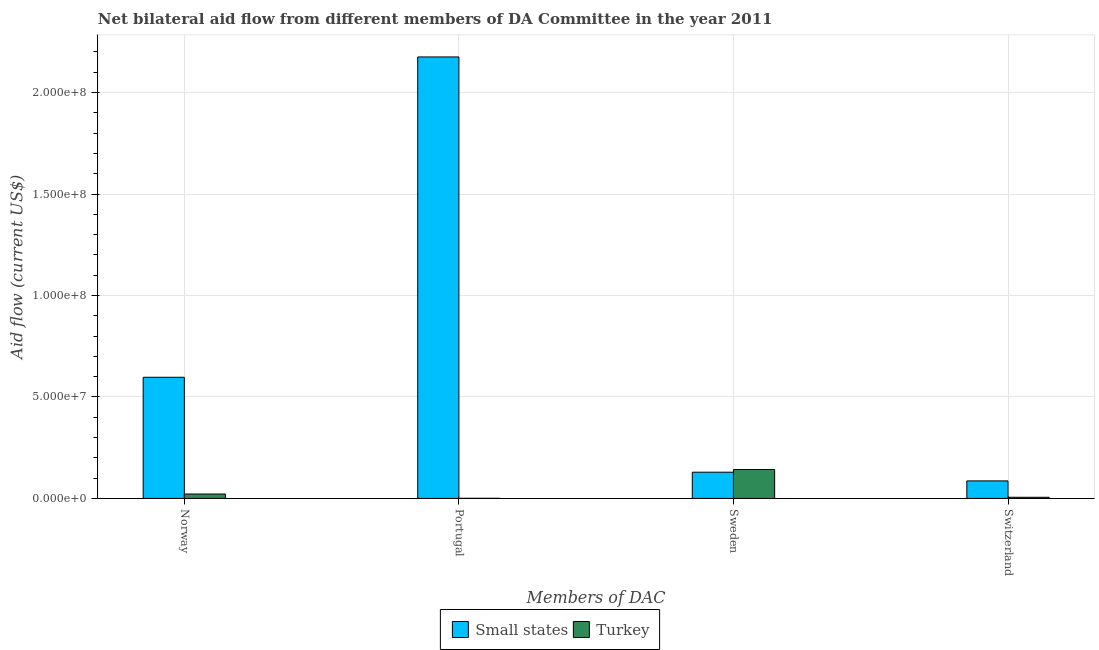How many different coloured bars are there?
Keep it short and to the point. 2. Are the number of bars per tick equal to the number of legend labels?
Your answer should be compact. Yes. Are the number of bars on each tick of the X-axis equal?
Offer a very short reply. Yes. How many bars are there on the 1st tick from the right?
Make the answer very short. 2. What is the label of the 3rd group of bars from the left?
Keep it short and to the point. Sweden. What is the amount of aid given by sweden in Small states?
Provide a short and direct response. 1.29e+07. Across all countries, what is the maximum amount of aid given by switzerland?
Your answer should be very brief. 8.64e+06. Across all countries, what is the minimum amount of aid given by sweden?
Ensure brevity in your answer.  1.29e+07. In which country was the amount of aid given by sweden maximum?
Provide a short and direct response. Turkey. In which country was the amount of aid given by portugal minimum?
Your answer should be very brief. Turkey. What is the total amount of aid given by norway in the graph?
Provide a short and direct response. 6.19e+07. What is the difference between the amount of aid given by sweden in Turkey and that in Small states?
Make the answer very short. 1.32e+06. What is the difference between the amount of aid given by sweden in Turkey and the amount of aid given by norway in Small states?
Your answer should be very brief. -4.54e+07. What is the average amount of aid given by switzerland per country?
Make the answer very short. 4.60e+06. What is the difference between the amount of aid given by norway and amount of aid given by sweden in Turkey?
Provide a succinct answer. -1.21e+07. What is the ratio of the amount of aid given by sweden in Small states to that in Turkey?
Ensure brevity in your answer.  0.91. Is the amount of aid given by switzerland in Small states less than that in Turkey?
Provide a short and direct response. No. Is the difference between the amount of aid given by switzerland in Turkey and Small states greater than the difference between the amount of aid given by sweden in Turkey and Small states?
Provide a short and direct response. No. What is the difference between the highest and the second highest amount of aid given by sweden?
Provide a succinct answer. 1.32e+06. What is the difference between the highest and the lowest amount of aid given by portugal?
Your answer should be very brief. 2.17e+08. In how many countries, is the amount of aid given by switzerland greater than the average amount of aid given by switzerland taken over all countries?
Keep it short and to the point. 1. Is it the case that in every country, the sum of the amount of aid given by switzerland and amount of aid given by norway is greater than the sum of amount of aid given by portugal and amount of aid given by sweden?
Offer a terse response. No. What does the 2nd bar from the left in Portugal represents?
Provide a succinct answer. Turkey. What does the 2nd bar from the right in Norway represents?
Your answer should be very brief. Small states. How many bars are there?
Ensure brevity in your answer.  8. How many countries are there in the graph?
Give a very brief answer. 2. Are the values on the major ticks of Y-axis written in scientific E-notation?
Provide a succinct answer. Yes. Does the graph contain any zero values?
Your answer should be compact. No. How many legend labels are there?
Your answer should be compact. 2. What is the title of the graph?
Offer a terse response. Net bilateral aid flow from different members of DA Committee in the year 2011. What is the label or title of the X-axis?
Provide a succinct answer. Members of DAC. What is the Aid flow (current US$) of Small states in Norway?
Keep it short and to the point. 5.97e+07. What is the Aid flow (current US$) in Turkey in Norway?
Give a very brief answer. 2.17e+06. What is the Aid flow (current US$) of Small states in Portugal?
Give a very brief answer. 2.18e+08. What is the Aid flow (current US$) in Small states in Sweden?
Your response must be concise. 1.29e+07. What is the Aid flow (current US$) in Turkey in Sweden?
Offer a very short reply. 1.42e+07. What is the Aid flow (current US$) in Small states in Switzerland?
Offer a terse response. 8.64e+06. What is the Aid flow (current US$) of Turkey in Switzerland?
Offer a very short reply. 5.70e+05. Across all Members of DAC, what is the maximum Aid flow (current US$) of Small states?
Your answer should be very brief. 2.18e+08. Across all Members of DAC, what is the maximum Aid flow (current US$) in Turkey?
Your answer should be compact. 1.42e+07. Across all Members of DAC, what is the minimum Aid flow (current US$) in Small states?
Your answer should be compact. 8.64e+06. What is the total Aid flow (current US$) in Small states in the graph?
Offer a terse response. 2.99e+08. What is the total Aid flow (current US$) in Turkey in the graph?
Provide a succinct answer. 1.70e+07. What is the difference between the Aid flow (current US$) in Small states in Norway and that in Portugal?
Make the answer very short. -1.58e+08. What is the difference between the Aid flow (current US$) of Turkey in Norway and that in Portugal?
Keep it short and to the point. 2.11e+06. What is the difference between the Aid flow (current US$) in Small states in Norway and that in Sweden?
Provide a succinct answer. 4.68e+07. What is the difference between the Aid flow (current US$) of Turkey in Norway and that in Sweden?
Keep it short and to the point. -1.21e+07. What is the difference between the Aid flow (current US$) of Small states in Norway and that in Switzerland?
Make the answer very short. 5.11e+07. What is the difference between the Aid flow (current US$) of Turkey in Norway and that in Switzerland?
Offer a terse response. 1.60e+06. What is the difference between the Aid flow (current US$) of Small states in Portugal and that in Sweden?
Provide a short and direct response. 2.05e+08. What is the difference between the Aid flow (current US$) of Turkey in Portugal and that in Sweden?
Your answer should be compact. -1.42e+07. What is the difference between the Aid flow (current US$) of Small states in Portugal and that in Switzerland?
Ensure brevity in your answer.  2.09e+08. What is the difference between the Aid flow (current US$) of Turkey in Portugal and that in Switzerland?
Provide a succinct answer. -5.10e+05. What is the difference between the Aid flow (current US$) in Small states in Sweden and that in Switzerland?
Give a very brief answer. 4.29e+06. What is the difference between the Aid flow (current US$) of Turkey in Sweden and that in Switzerland?
Give a very brief answer. 1.37e+07. What is the difference between the Aid flow (current US$) of Small states in Norway and the Aid flow (current US$) of Turkey in Portugal?
Provide a succinct answer. 5.96e+07. What is the difference between the Aid flow (current US$) in Small states in Norway and the Aid flow (current US$) in Turkey in Sweden?
Keep it short and to the point. 4.54e+07. What is the difference between the Aid flow (current US$) of Small states in Norway and the Aid flow (current US$) of Turkey in Switzerland?
Provide a short and direct response. 5.91e+07. What is the difference between the Aid flow (current US$) of Small states in Portugal and the Aid flow (current US$) of Turkey in Sweden?
Keep it short and to the point. 2.03e+08. What is the difference between the Aid flow (current US$) of Small states in Portugal and the Aid flow (current US$) of Turkey in Switzerland?
Your answer should be compact. 2.17e+08. What is the difference between the Aid flow (current US$) of Small states in Sweden and the Aid flow (current US$) of Turkey in Switzerland?
Keep it short and to the point. 1.24e+07. What is the average Aid flow (current US$) of Small states per Members of DAC?
Your answer should be very brief. 7.47e+07. What is the average Aid flow (current US$) of Turkey per Members of DAC?
Your answer should be compact. 4.26e+06. What is the difference between the Aid flow (current US$) in Small states and Aid flow (current US$) in Turkey in Norway?
Provide a succinct answer. 5.75e+07. What is the difference between the Aid flow (current US$) in Small states and Aid flow (current US$) in Turkey in Portugal?
Make the answer very short. 2.17e+08. What is the difference between the Aid flow (current US$) in Small states and Aid flow (current US$) in Turkey in Sweden?
Keep it short and to the point. -1.32e+06. What is the difference between the Aid flow (current US$) of Small states and Aid flow (current US$) of Turkey in Switzerland?
Offer a very short reply. 8.07e+06. What is the ratio of the Aid flow (current US$) of Small states in Norway to that in Portugal?
Provide a short and direct response. 0.27. What is the ratio of the Aid flow (current US$) in Turkey in Norway to that in Portugal?
Offer a terse response. 36.17. What is the ratio of the Aid flow (current US$) in Small states in Norway to that in Sweden?
Give a very brief answer. 4.62. What is the ratio of the Aid flow (current US$) of Turkey in Norway to that in Sweden?
Give a very brief answer. 0.15. What is the ratio of the Aid flow (current US$) in Small states in Norway to that in Switzerland?
Ensure brevity in your answer.  6.91. What is the ratio of the Aid flow (current US$) in Turkey in Norway to that in Switzerland?
Keep it short and to the point. 3.81. What is the ratio of the Aid flow (current US$) of Small states in Portugal to that in Sweden?
Provide a succinct answer. 16.82. What is the ratio of the Aid flow (current US$) of Turkey in Portugal to that in Sweden?
Keep it short and to the point. 0. What is the ratio of the Aid flow (current US$) of Small states in Portugal to that in Switzerland?
Ensure brevity in your answer.  25.18. What is the ratio of the Aid flow (current US$) of Turkey in Portugal to that in Switzerland?
Offer a very short reply. 0.11. What is the ratio of the Aid flow (current US$) in Small states in Sweden to that in Switzerland?
Your answer should be very brief. 1.5. What is the ratio of the Aid flow (current US$) in Turkey in Sweden to that in Switzerland?
Your answer should be very brief. 25. What is the difference between the highest and the second highest Aid flow (current US$) in Small states?
Ensure brevity in your answer.  1.58e+08. What is the difference between the highest and the second highest Aid flow (current US$) in Turkey?
Make the answer very short. 1.21e+07. What is the difference between the highest and the lowest Aid flow (current US$) of Small states?
Your answer should be compact. 2.09e+08. What is the difference between the highest and the lowest Aid flow (current US$) in Turkey?
Give a very brief answer. 1.42e+07. 